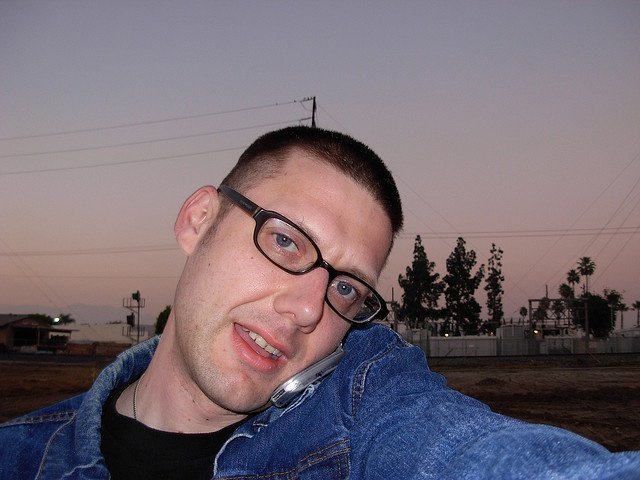Describe the objects in this image and their specific colors. I can see people in gray, navy, black, and salmon tones and cell phone in gray, black, and darkgray tones in this image. 